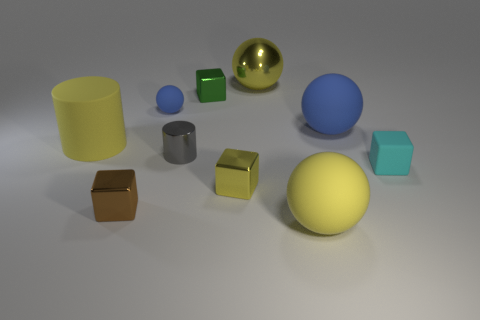Subtract all small blue rubber balls. How many balls are left? 3 Subtract all blue balls. How many balls are left? 2 Subtract all cyan cylinders. How many yellow balls are left? 2 Subtract all spheres. How many objects are left? 6 Add 7 tiny gray metal things. How many tiny gray metal things are left? 8 Add 9 tiny blue rubber balls. How many tiny blue rubber balls exist? 10 Subtract 1 cyan cubes. How many objects are left? 9 Subtract 4 balls. How many balls are left? 0 Subtract all green cylinders. Subtract all green blocks. How many cylinders are left? 2 Subtract all small blocks. Subtract all big yellow rubber spheres. How many objects are left? 5 